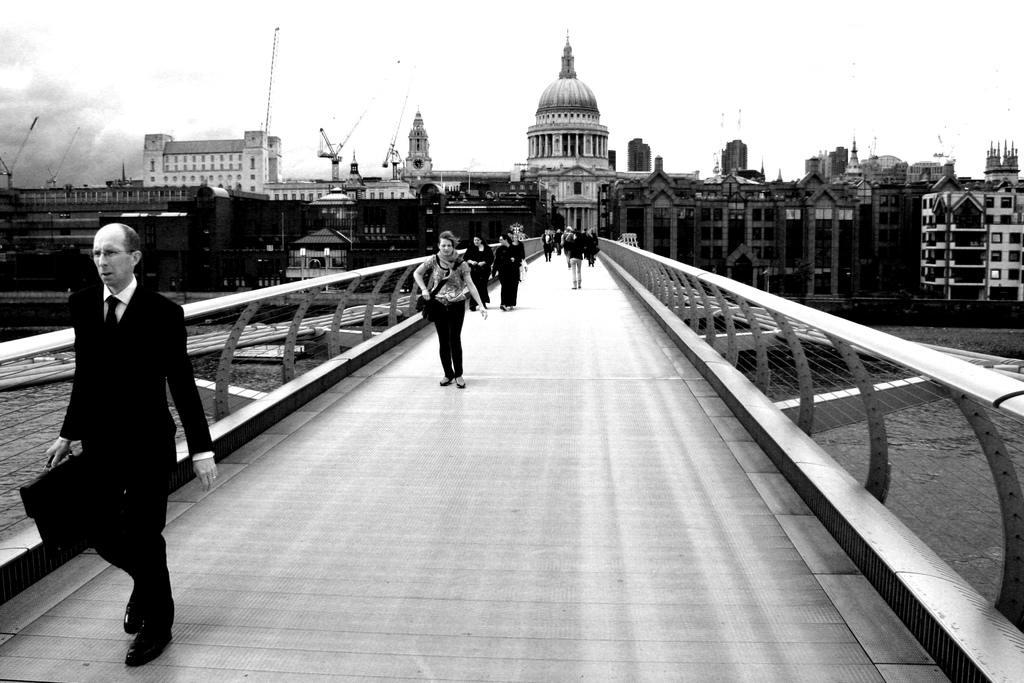Describe this image in one or two sentences. This is a black and white image and here we can see people on the bridge and one of them is holding a bag and some are wearing bags. In the background, there are buildings, boards, poles and there is a road. At the top, there is sky. 